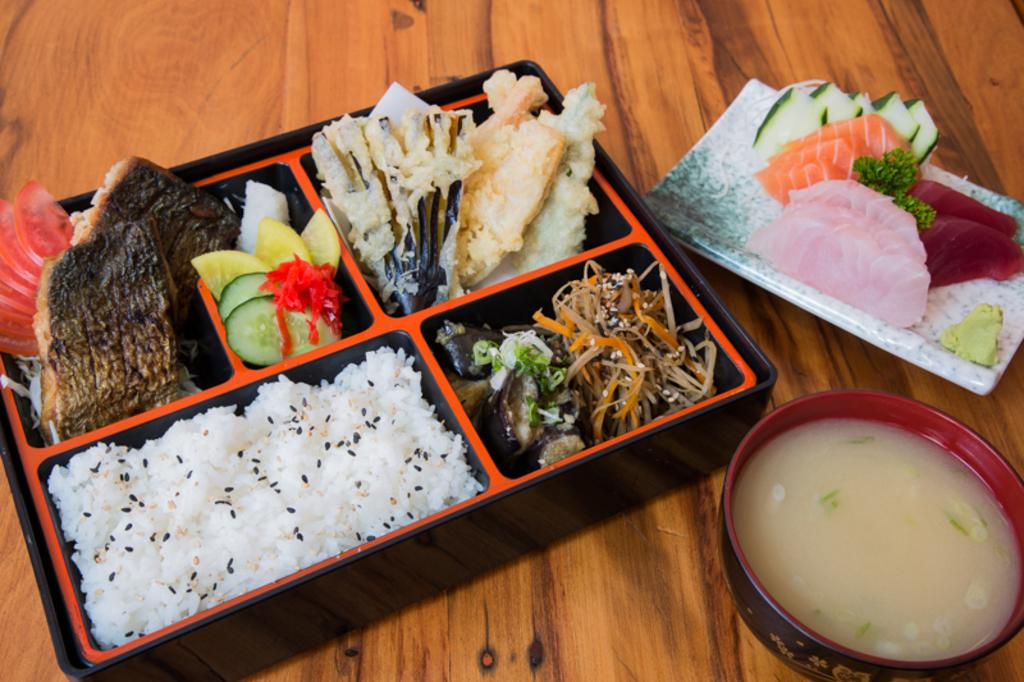What type of container is present in the image? There is a box, a plate, and a bowl in the image. What is on the plate and in the box? There is food on the plate and in the box. What type of food is in the bowl? There is soup in the bowl. What type of surface is visible at the bottom of the image? There is a wooden surface visible at the bottom of the image. What type of silver is used to treat the pig in the image? There is no silver or pig present in the image. 